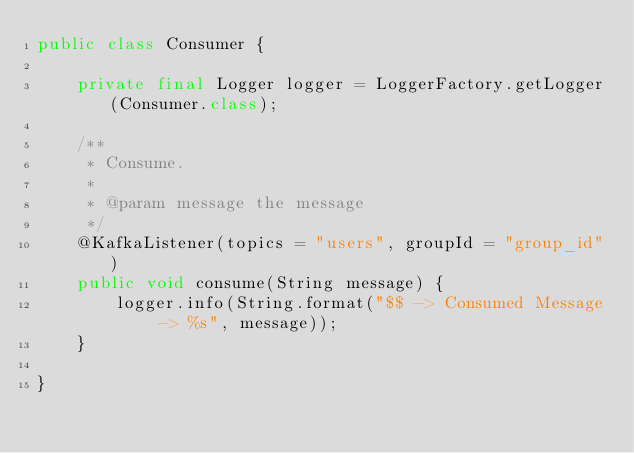<code> <loc_0><loc_0><loc_500><loc_500><_Java_>public class Consumer {

    private final Logger logger = LoggerFactory.getLogger(Consumer.class);

    /**
     * Consume.
     *
     * @param message the message
     */
    @KafkaListener(topics = "users", groupId = "group_id")
    public void consume(String message) {
        logger.info(String.format("$$ -> Consumed Message -> %s", message));
    }

}
</code> 